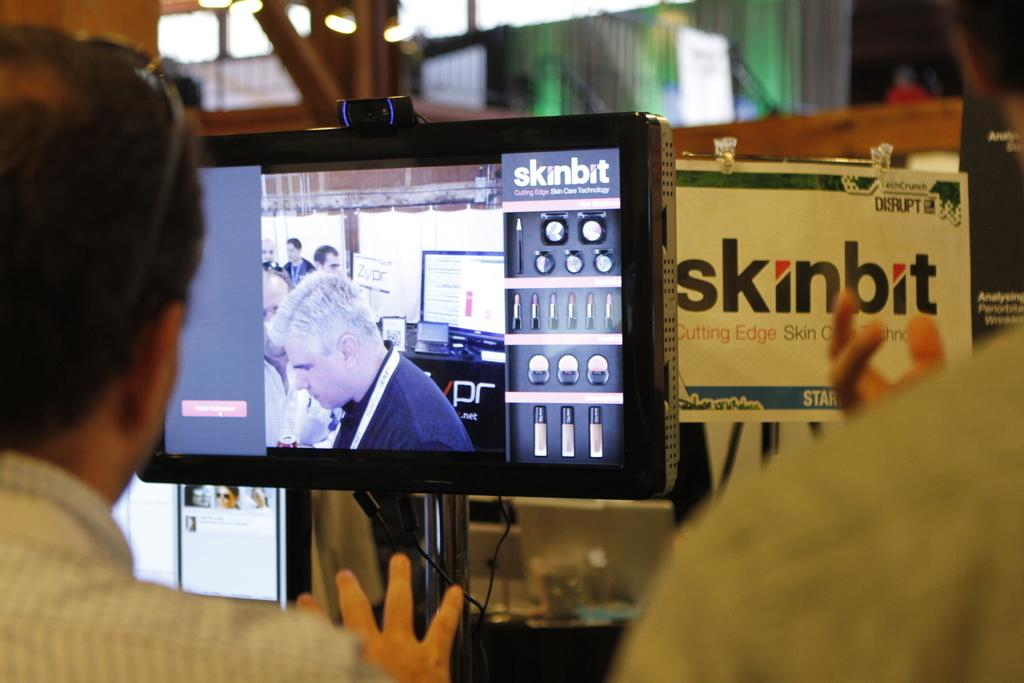<image>
Describe the image concisely. a disply with a flat screen tv advertising the skinbit 